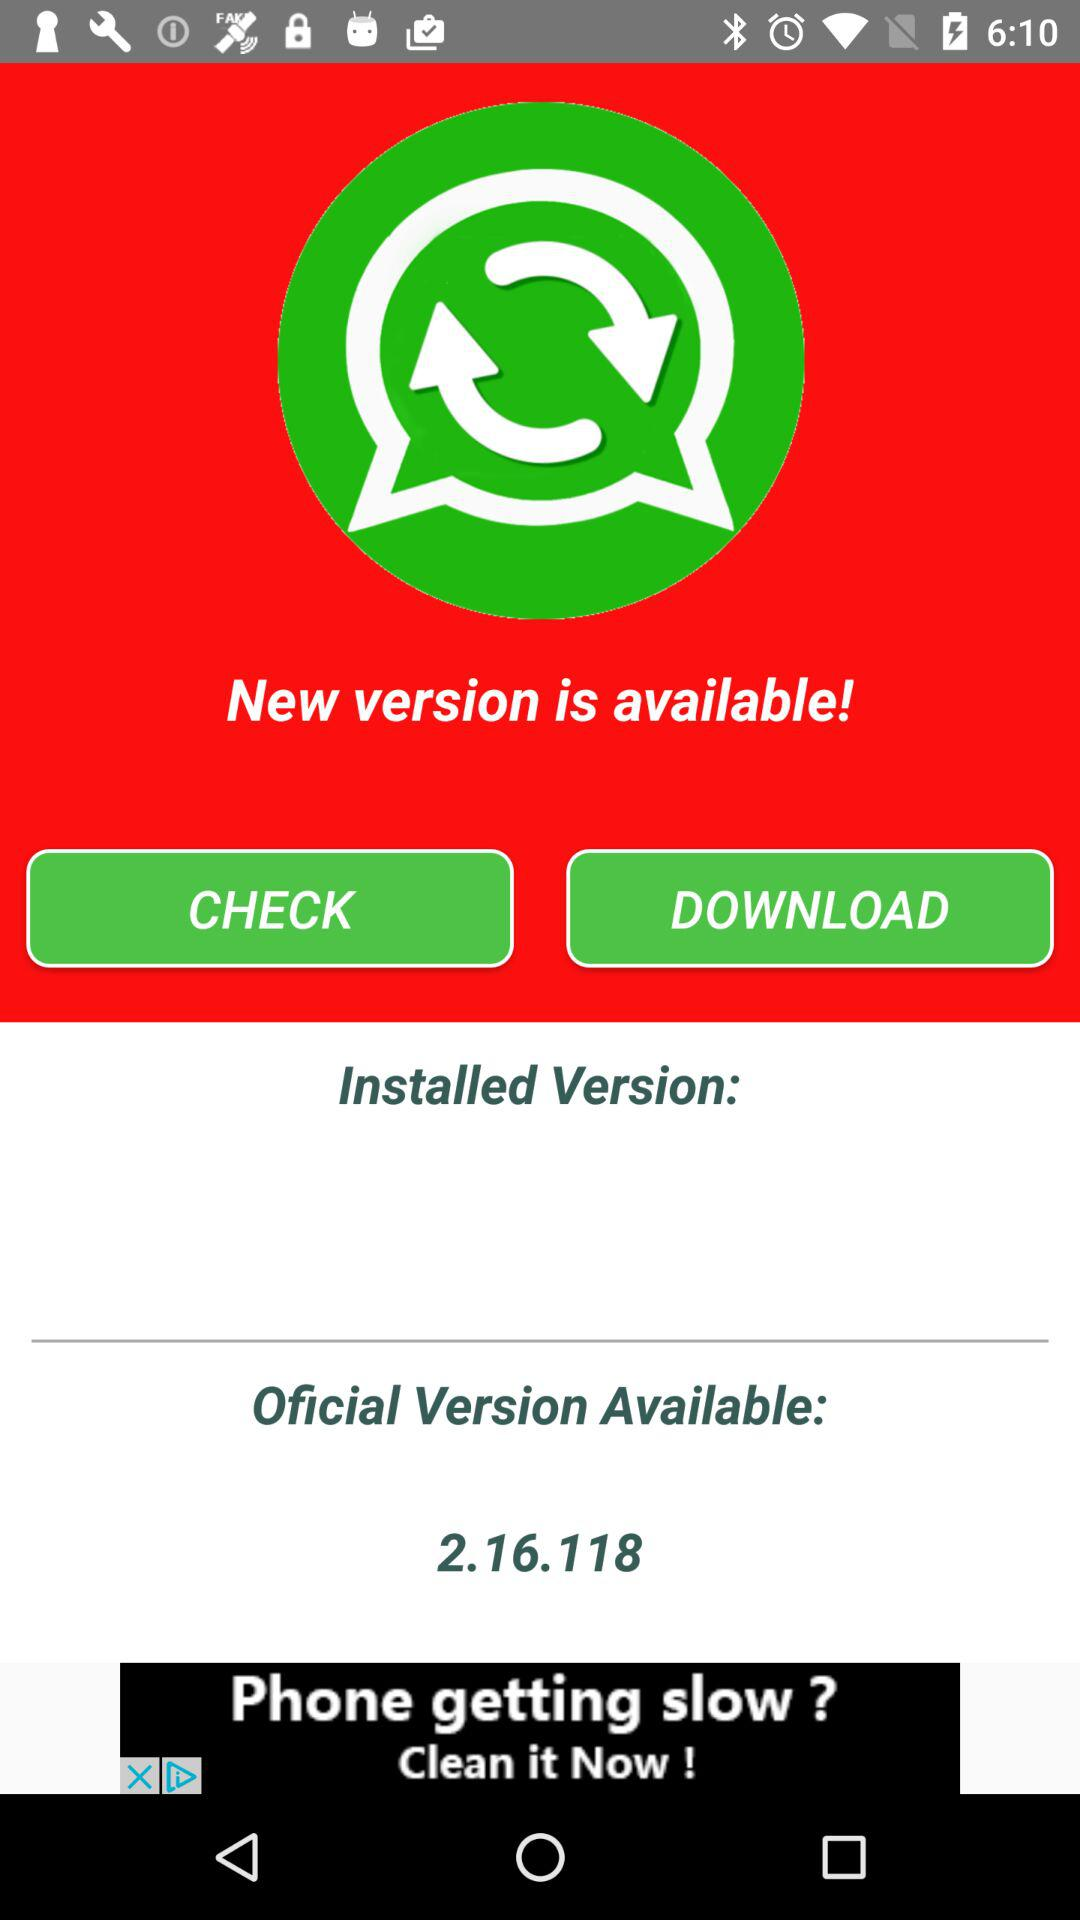What is the version of the app that is currently installed?
Answer the question using a single word or phrase. 2.16.118 